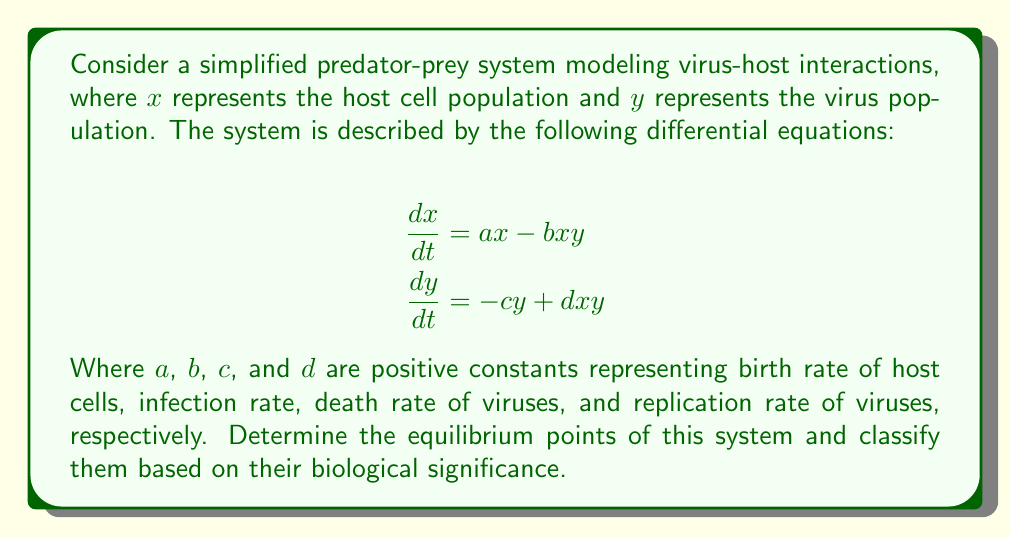Provide a solution to this math problem. To find the equilibrium points, we set both equations equal to zero and solve for x and y:

1) Set equations to zero:
   $$ax - bxy = 0$$
   $$-cy + dxy = 0$$

2) From the first equation:
   $$x(a - by) = 0$$
   This gives us two cases: $x = 0$ or $y = \frac{a}{b}$

3) From the second equation:
   $$y(-c + dx) = 0$$
   This gives us two cases: $y = 0$ or $x = \frac{c}{d}$

4) Combining these results, we get three equilibrium points:
   i) $(0, 0)$: Both populations are extinct
   ii) $(\frac{a}{b}, 0)$: Only host cells survive
   iii) $(\frac{c}{d}, \frac{a}{b})$: Coexistence of host cells and viruses

5) Biological significance:
   - $(0, 0)$: Trivial equilibrium, both populations extinct
   - $(\frac{a}{b}, 0)$: Virus-free equilibrium, only host cells present
   - $(\frac{c}{d}, \frac{a}{b})$: Endemic equilibrium, both populations coexist

These equilibrium points provide insights into the long-term behavior of the virus-host system under different conditions.
Answer: $(0, 0)$, $(\frac{a}{b}, 0)$, and $(\frac{c}{d}, \frac{a}{b})$ 